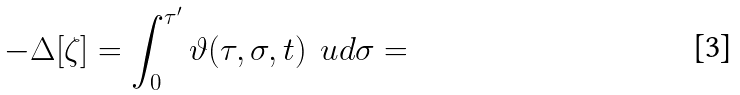<formula> <loc_0><loc_0><loc_500><loc_500>- \Delta [ \zeta ] = \int _ { 0 } ^ { \tau ^ { \prime } } \vartheta ( \tau , \sigma , t ) \, { \ u d } \sigma =</formula> 